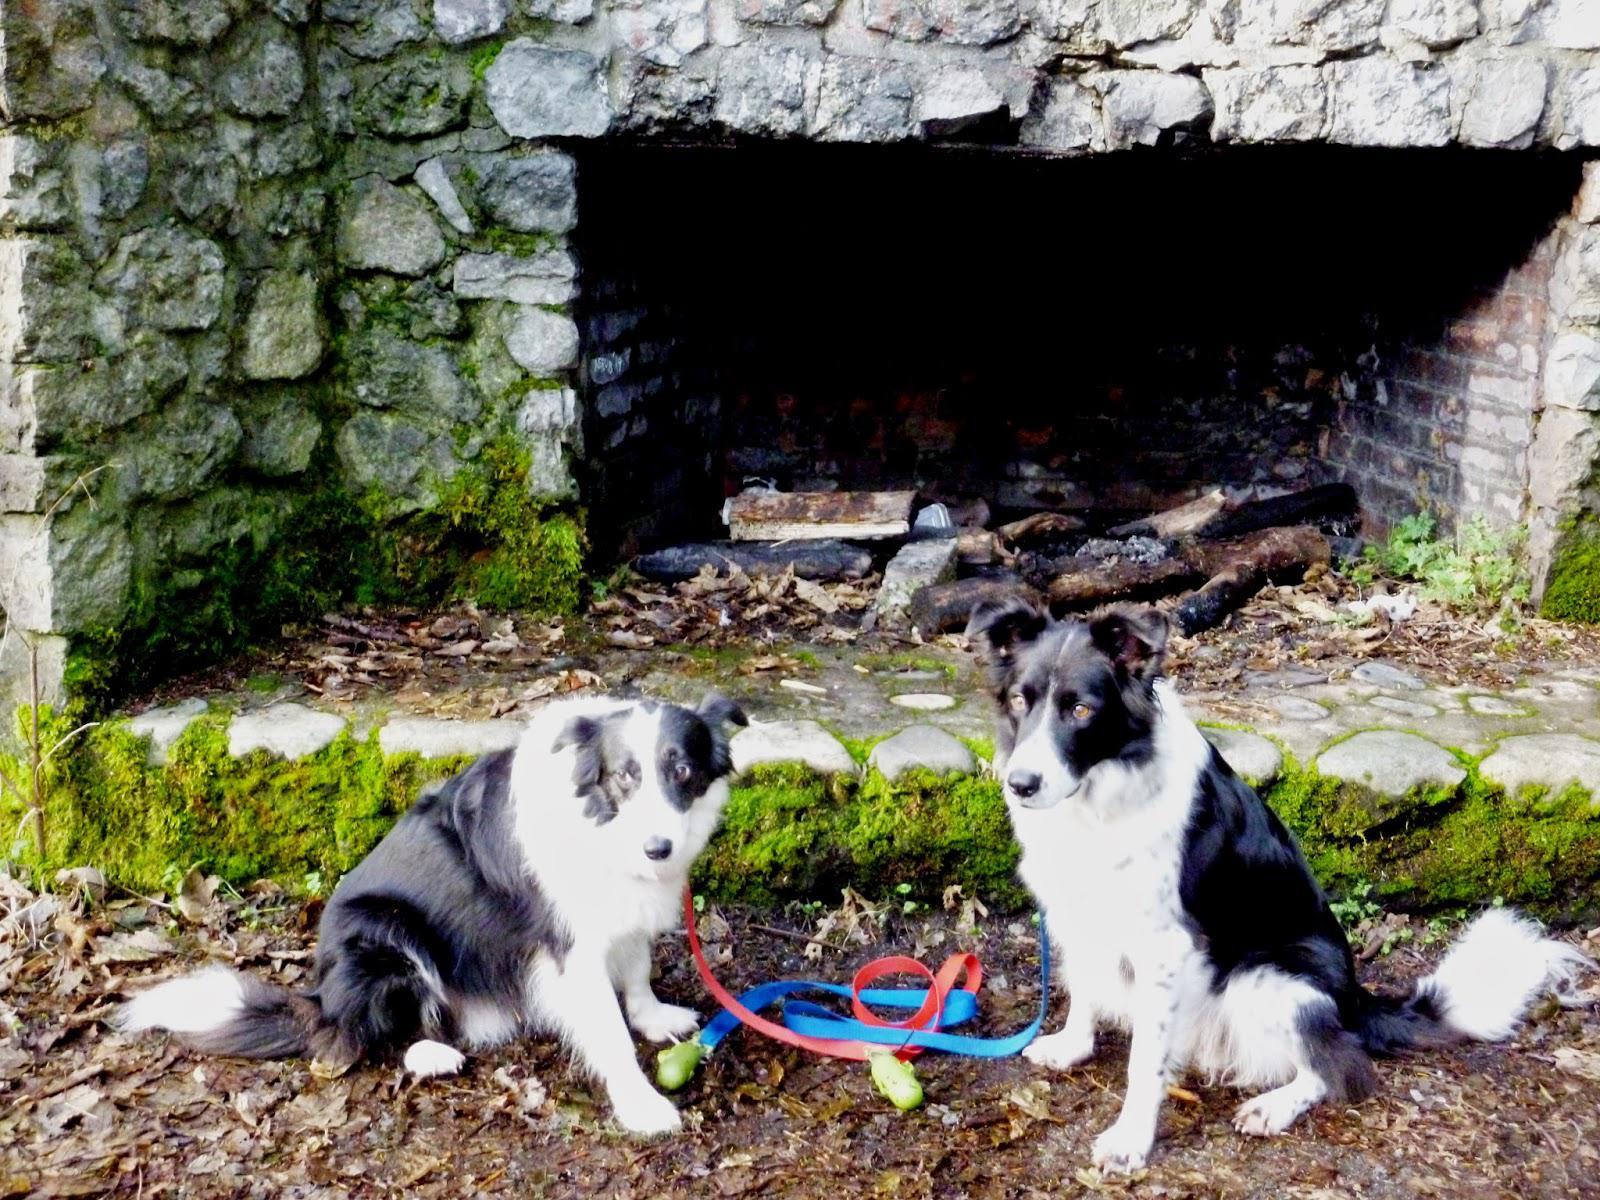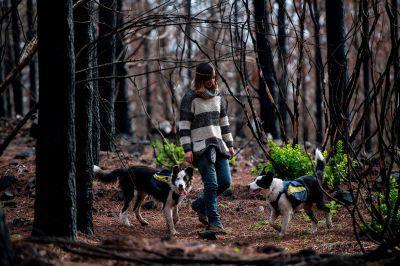The first image is the image on the left, the second image is the image on the right. Evaluate the accuracy of this statement regarding the images: "The left image contains two dogs that are not wearing vests, and the right image features a girl in a striped sweater with at least one dog wearing a vest pack.". Is it true? Answer yes or no. Yes. The first image is the image on the left, the second image is the image on the right. Given the left and right images, does the statement "One or more of the images has three dogs." hold true? Answer yes or no. No. 